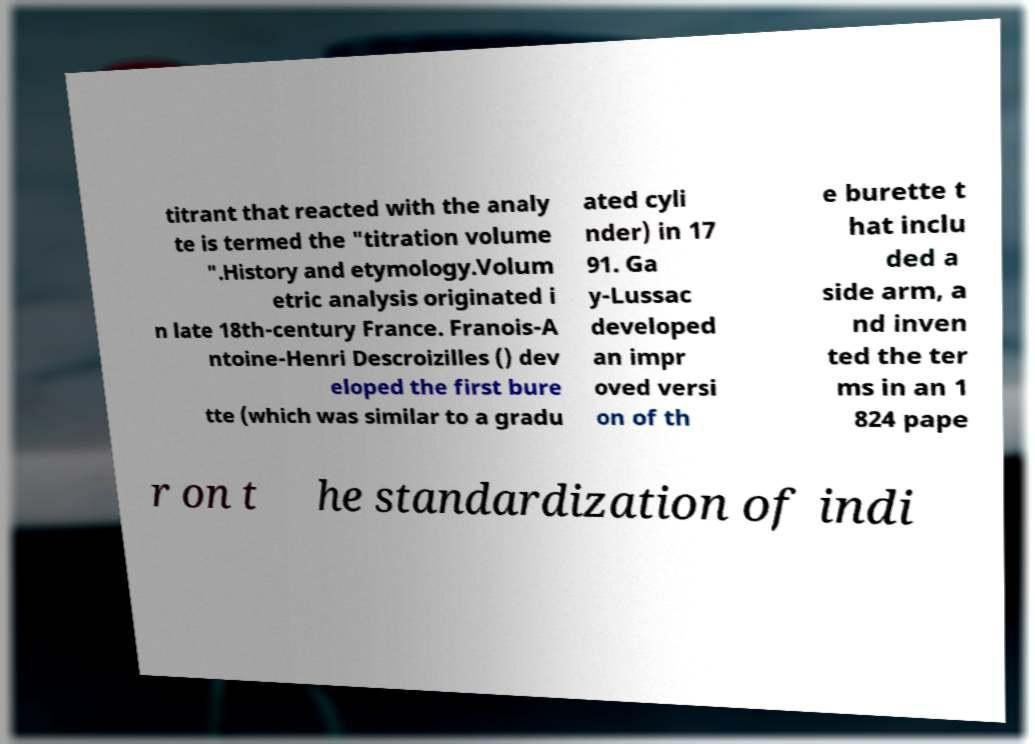Could you extract and type out the text from this image? titrant that reacted with the analy te is termed the "titration volume ".History and etymology.Volum etric analysis originated i n late 18th-century France. Franois-A ntoine-Henri Descroizilles () dev eloped the first bure tte (which was similar to a gradu ated cyli nder) in 17 91. Ga y-Lussac developed an impr oved versi on of th e burette t hat inclu ded a side arm, a nd inven ted the ter ms in an 1 824 pape r on t he standardization of indi 